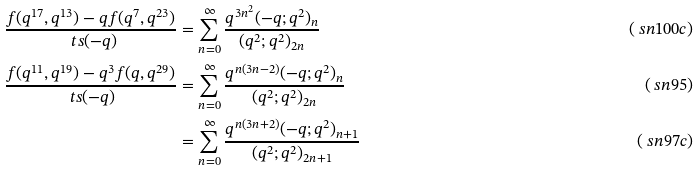Convert formula to latex. <formula><loc_0><loc_0><loc_500><loc_500>\frac { f ( q ^ { 1 7 } , q ^ { 1 3 } ) - q f ( q ^ { 7 } , q ^ { 2 3 } ) } { \ t s ( - q ) } & = \sum _ { n = 0 } ^ { \infty } \frac { q ^ { 3 n ^ { 2 } } ( - q ; q ^ { 2 } ) _ { n } } { ( q ^ { 2 } ; q ^ { 2 } ) _ { 2 n } } & ( \ s n { 1 0 0 c } ) \\ \frac { f ( q ^ { 1 1 } , q ^ { 1 9 } ) - q ^ { 3 } f ( q , q ^ { 2 9 } ) } { \ t s ( - q ) } & = \sum _ { n = 0 } ^ { \infty } \frac { q ^ { n ( 3 n - 2 ) } ( - q ; q ^ { 2 } ) _ { n } } { ( q ^ { 2 } ; q ^ { 2 } ) _ { 2 n } } & ( \ s n { 9 5 } ) \\ & = \sum _ { n = 0 } ^ { \infty } \frac { q ^ { n ( 3 n + 2 ) } ( - q ; q ^ { 2 } ) _ { n + 1 } } { ( q ^ { 2 } ; q ^ { 2 } ) _ { 2 n + 1 } } & ( \ s n { 9 7 c } )</formula> 